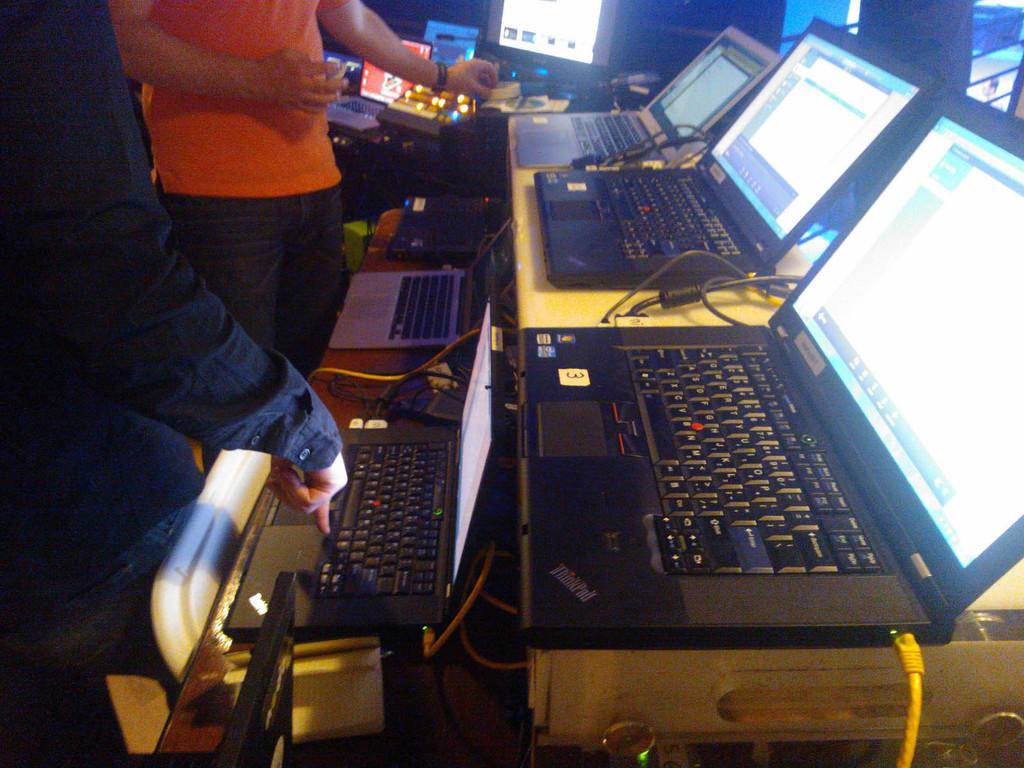Provide a one-sentence caption for the provided image. A series of laptops side by side one of which has a sticker with the number 3 on it. 